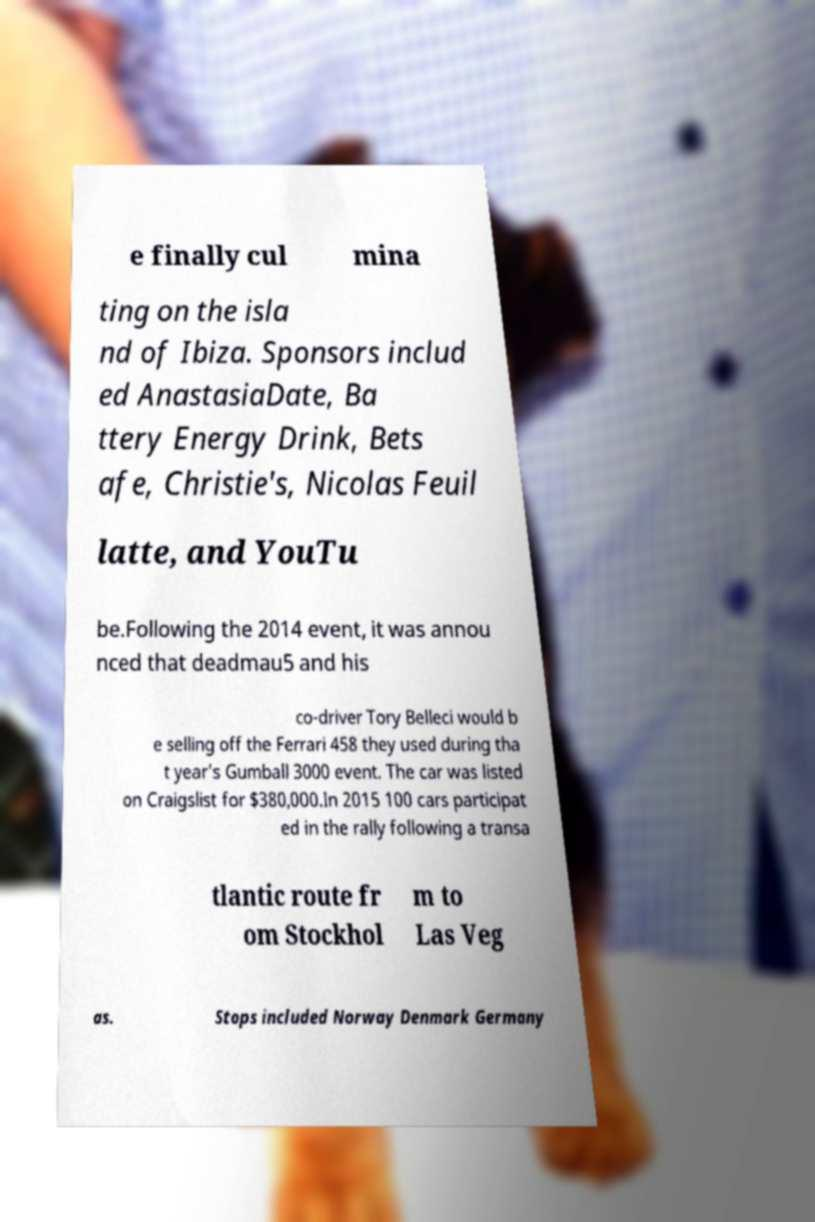I need the written content from this picture converted into text. Can you do that? e finally cul mina ting on the isla nd of Ibiza. Sponsors includ ed AnastasiaDate, Ba ttery Energy Drink, Bets afe, Christie's, Nicolas Feuil latte, and YouTu be.Following the 2014 event, it was annou nced that deadmau5 and his co-driver Tory Belleci would b e selling off the Ferrari 458 they used during tha t year's Gumball 3000 event. The car was listed on Craigslist for $380,000.In 2015 100 cars participat ed in the rally following a transa tlantic route fr om Stockhol m to Las Veg as. Stops included Norway Denmark Germany 